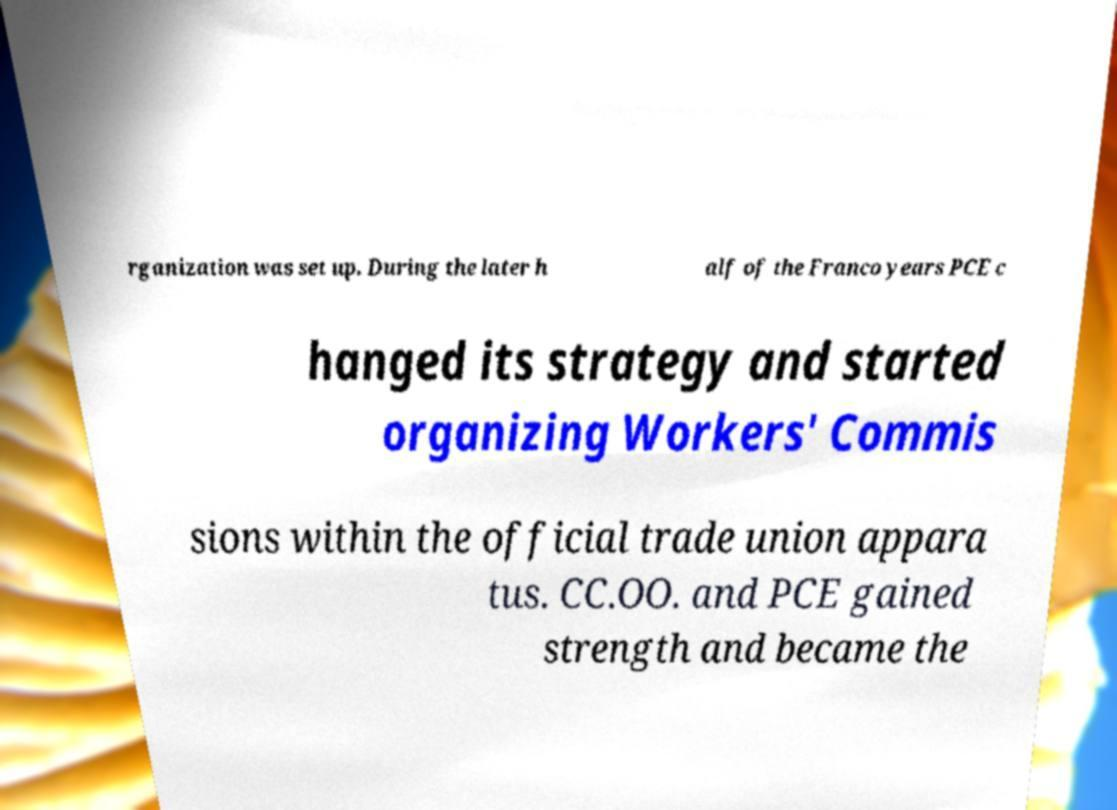Can you read and provide the text displayed in the image?This photo seems to have some interesting text. Can you extract and type it out for me? rganization was set up. During the later h alf of the Franco years PCE c hanged its strategy and started organizing Workers' Commis sions within the official trade union appara tus. CC.OO. and PCE gained strength and became the 